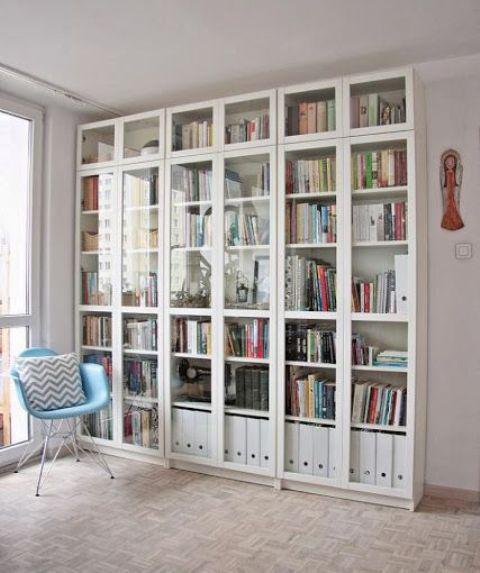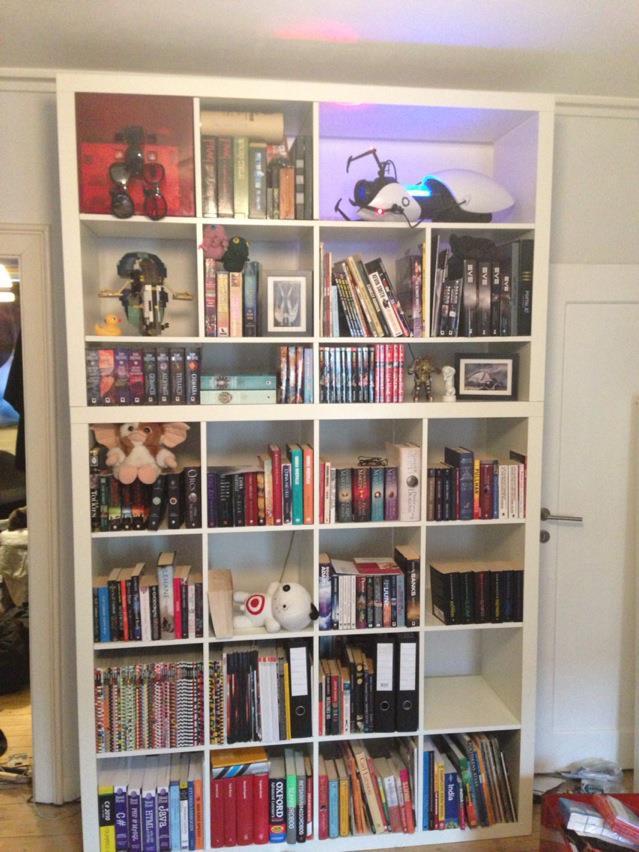The first image is the image on the left, the second image is the image on the right. Evaluate the accuracy of this statement regarding the images: "A chair is near a book shelf.". Is it true? Answer yes or no. Yes. 